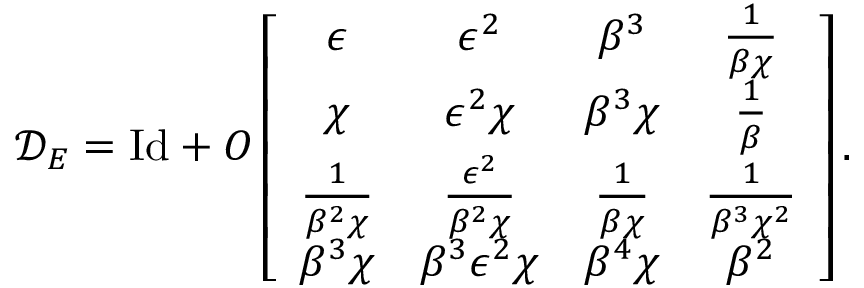<formula> <loc_0><loc_0><loc_500><loc_500>\mathcal { D } _ { E } = I d + O \left [ \begin{array} { c c c c } { \epsilon } & { \epsilon ^ { 2 } } & { \beta ^ { 3 } } & { \frac { 1 } { \beta \chi } } \\ { \chi } & { \epsilon ^ { 2 } \chi } & { \beta ^ { 3 } \chi } & { \frac { 1 } { \beta } } \\ { \frac { 1 } { \beta ^ { 2 } \chi } } & { \frac { \epsilon ^ { 2 } } { \beta ^ { 2 } \chi } } & { \frac { 1 } { \beta \chi } } & { \frac { 1 } { \beta ^ { 3 } \chi ^ { 2 } } } \\ { \beta ^ { 3 } \chi } & { \beta ^ { 3 } \epsilon ^ { 2 } \chi } & { \beta ^ { 4 } \chi } & { \beta ^ { 2 } } \end{array} \right ] .</formula> 